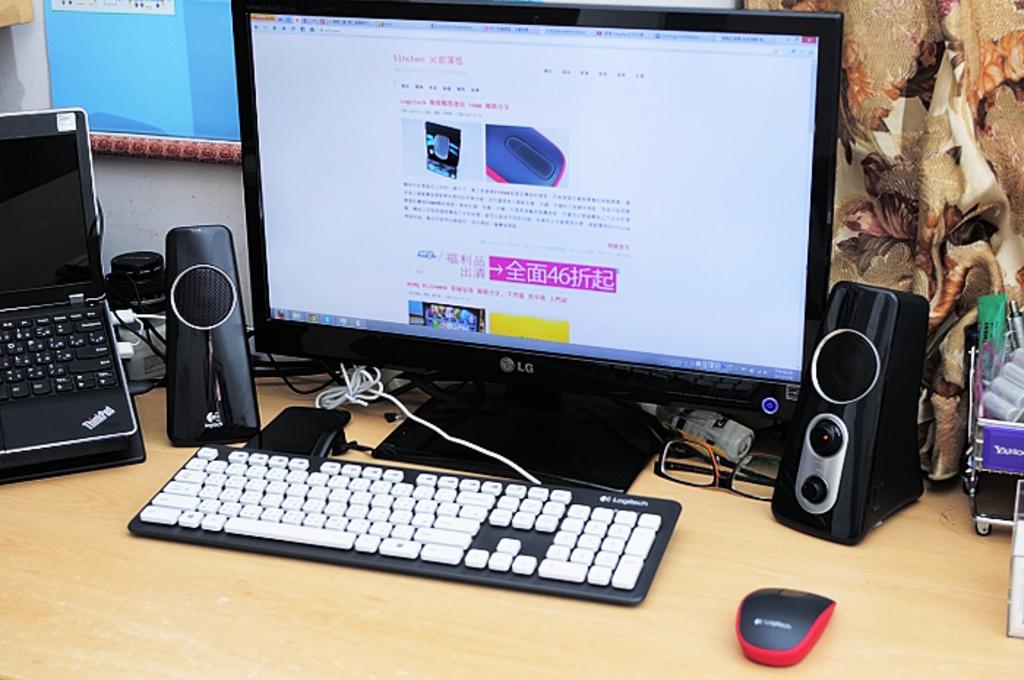What is the word on top of the black and red mouse?
Make the answer very short. Unanswerable. 